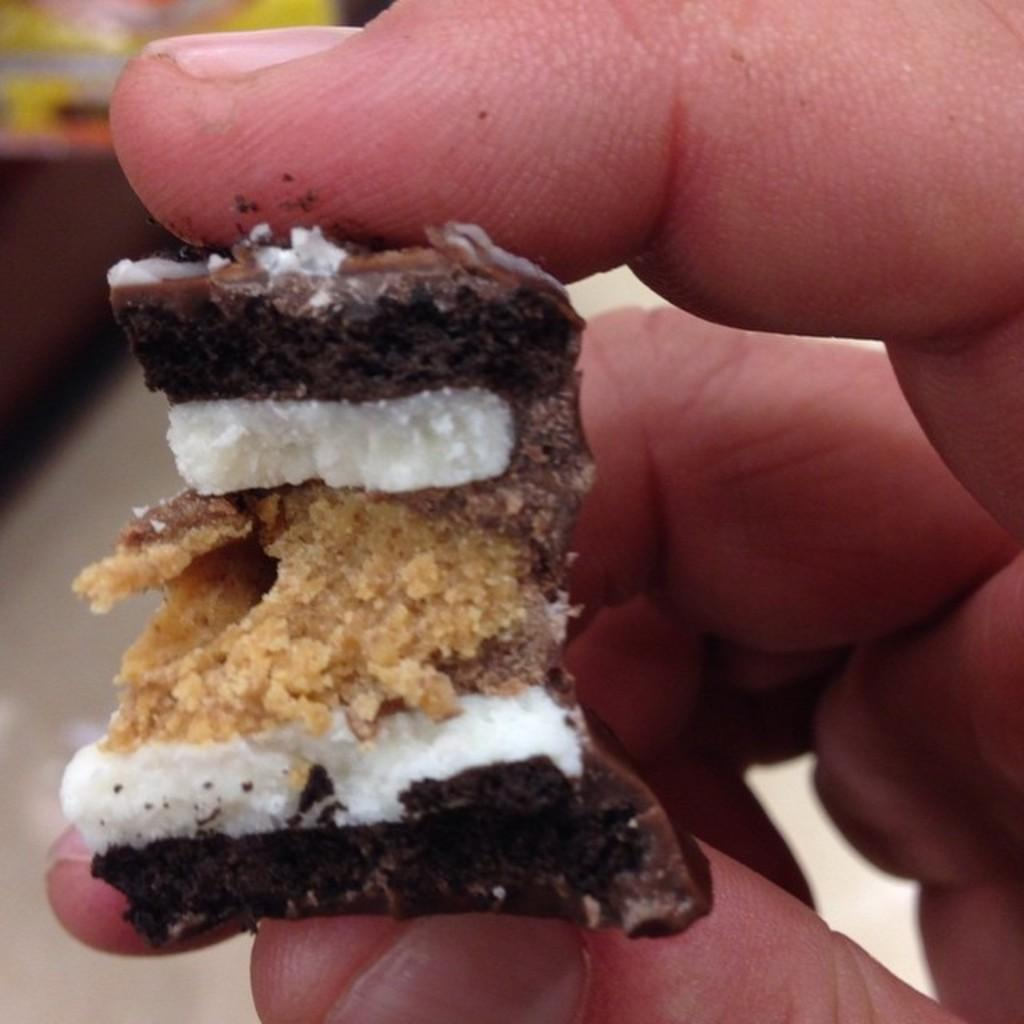What is the main subject of the image? There is a person in the image. What is the person holding in the image? The person is holding a food item. Can you describe the background of the image? The background of the image is blurry. What is the name of the food item the person is holding in the image? The provided facts do not mention the name of the food item, so it cannot be determined from the image. 